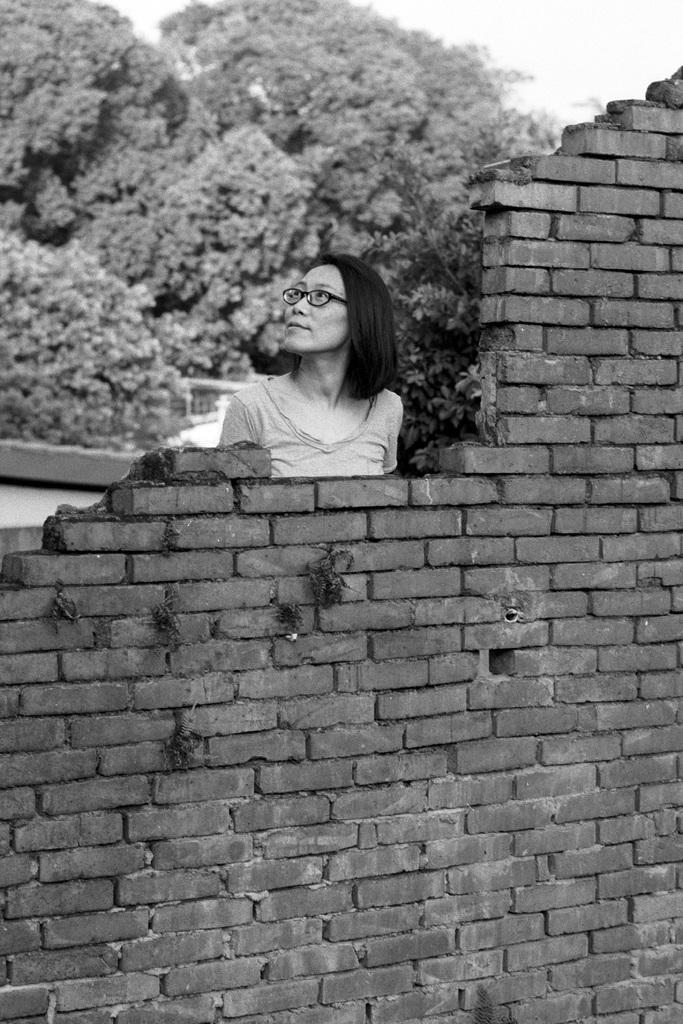What is present in the image that serves as a backdrop? There is a wall in the image. Who or what is the main subject in the image? There is a woman in the middle of the image. What can be seen in the distance behind the main subject? There are trees in the background of the image. How is the image presented in terms of color? The image is in black and white color. What type of dress is the woman wearing in the image? The image is in black and white color, so it is not possible to determine the type of dress the woman is wearing. Can you see any corn growing in the image? There is no corn present in the image. 